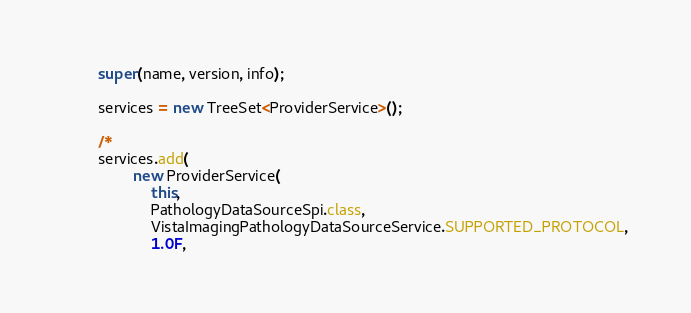<code> <loc_0><loc_0><loc_500><loc_500><_Java_>		super(name, version, info);

		services = new TreeSet<ProviderService>();
		
		/*
		services.add(
				new ProviderService(
					this,
					PathologyDataSourceSpi.class,
					VistaImagingPathologyDataSourceService.SUPPORTED_PROTOCOL,
					1.0F,</code> 